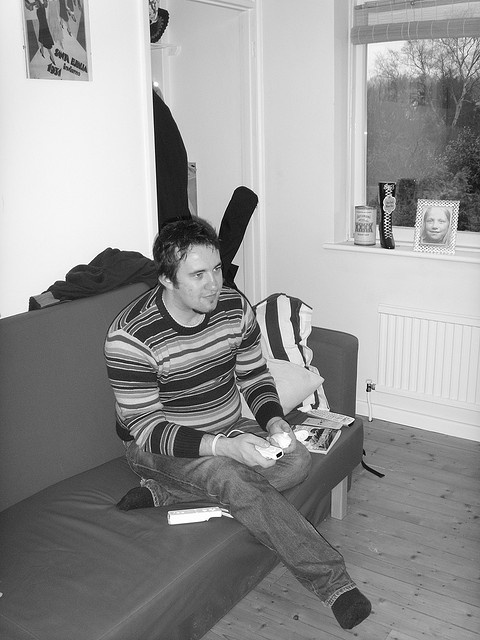Describe the objects in this image and their specific colors. I can see couch in lightgray, gray, black, white, and darkgray tones, people in lightgray, gray, darkgray, and black tones, remote in lightgray, white, darkgray, gray, and black tones, remote in lightgray, darkgray, gray, and black tones, and remote in lightgray, white, darkgray, black, and gray tones in this image. 